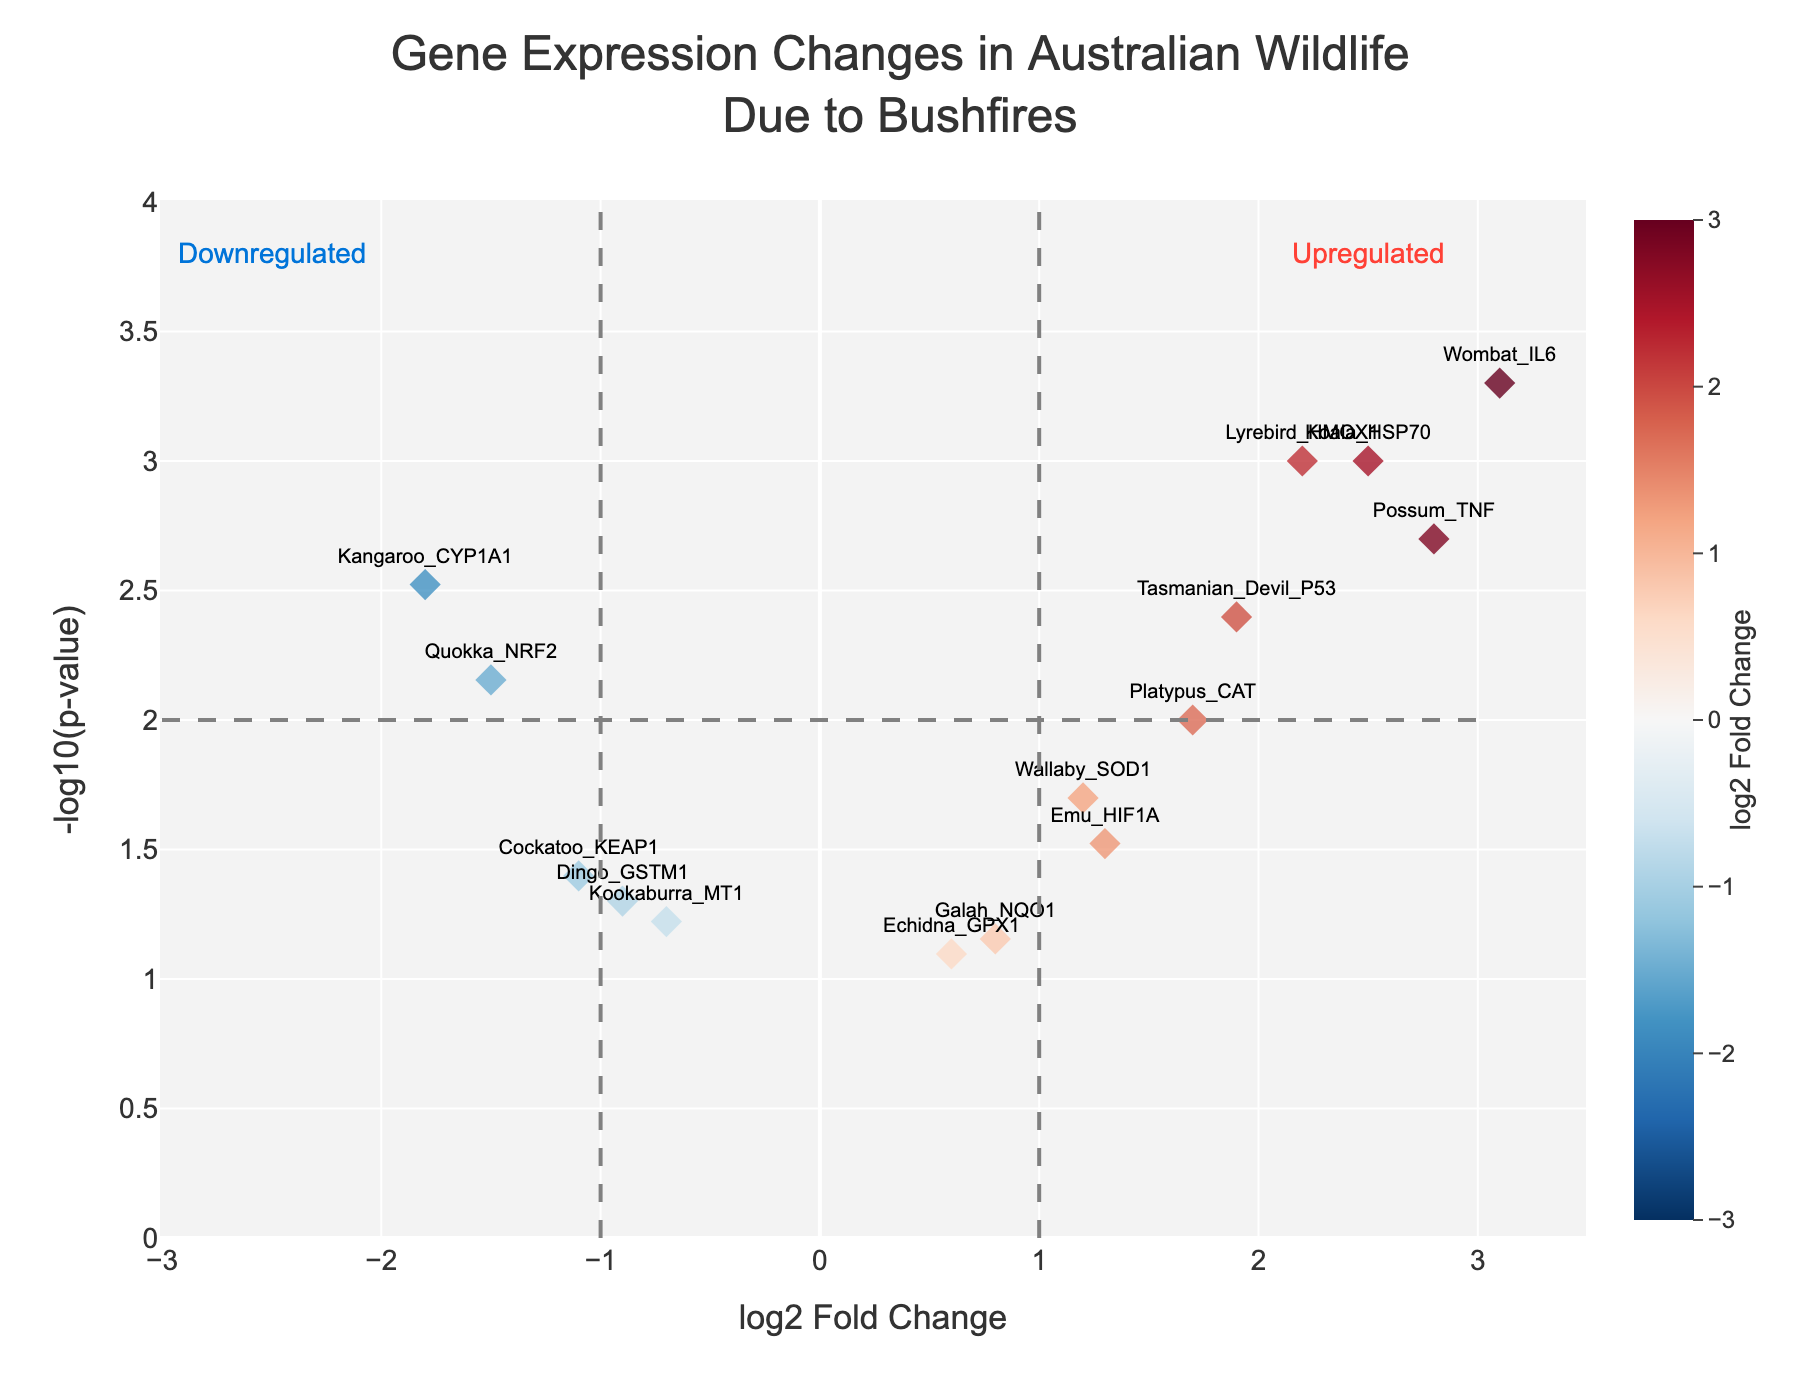What is the title of the figure? The title is usually found at the top part of the figure and summarizes the main focus of the plot. Here, it is clearly stated.
Answer: Gene Expression Changes in Australian Wildlife Due to Bushfires Which gene has the highest -log10(p-value)? The highest -log10(p-value) is represented by the point at the topmost part of the y-axis. It corresponds to Wombat_IL6.
Answer: Wombat_IL6 Which gene is the most upregulated? Upregulation is indicated by a high positive log2FoldChange value. By observing the points along the x-axis, the gene with the highest positive log2FoldChange is Wombat_IL6.
Answer: Wombat_IL6 Which gene is the most downregulated? Downregulation is indicated by a high negative log2FoldChange value. By observing the points along the x-axis, the gene with the highest negative log2FoldChange is Kangaroo_CYP1A1.
Answer: Kangaroo_CYP1A1 How many genes have a p-value less than 0.01? A p-value less than 0.01 corresponds to a -log10(p-value) greater than 2. By examining the y-axis, count the points above 2. There are 6 such points.
Answer: 6 What does the dashed grey line at 2 on the y-axis represent? The dashed grey line at -log10(p-value) = 2 indicates the p-value significance threshold, equivalent to a p-value of 0.01. Points above this line are considered statistically significant.
Answer: Significance threshold (p-value = 0.01) Which gene has both a p-value less than 0.01 and a negative log2FoldChange? Look for points to the right of -log10(p-value) = 2 and below log2FoldChange = 0. The gene that fits these criteria is Kangaroo_CYP1A1.
Answer: Kangaroo_CYP1A1 Which animal species has genes that are significantly upregulated? Examine the genes with high positive log2FoldChange values and -log10(p-value) greater than 2. Here, Wombat (Wombat_IL6), Possum (Possum_TNF), Koala (Koala_HSP70), and Lyrebird (Lyrebird_HMOX1) are upregulated.
Answer: Wombat, Possum, Koala, Lyrebird What is the log2FoldChange value for Emu_HIF1A, and is it significant? Find Emu_HIF1A on the plot and check its x and y coordinates. Emu_HIF1A has a log2FoldChange value of 1.3 and is below the -log10(p-value) threshold of 2, hence not considered statistically significant.
Answer: 1.3, not significant 